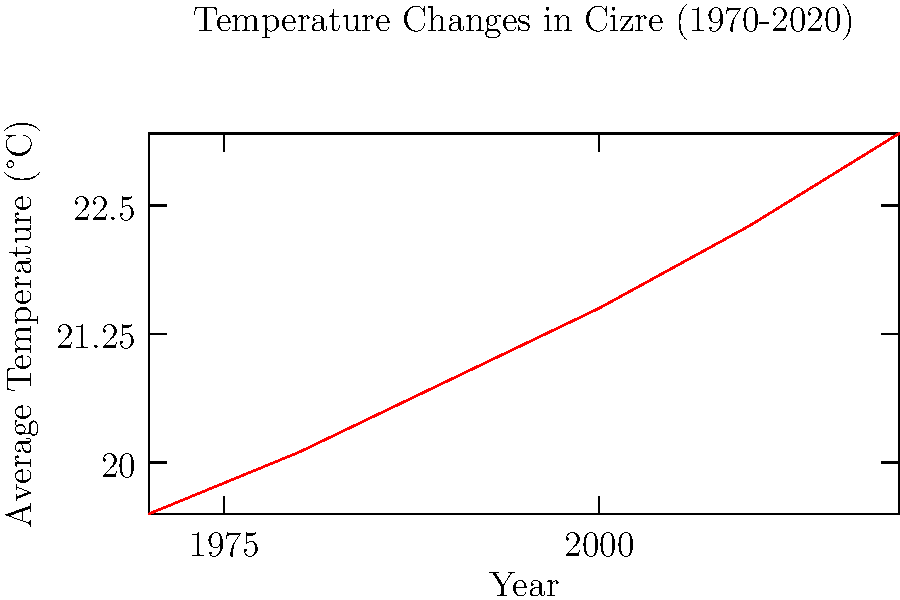Based on the line graph showing temperature changes in Cizre over the past 50 years, what is the approximate average rate of temperature increase per decade? To calculate the average rate of temperature increase per decade:

1. Calculate total temperature change:
   Final temperature (2020): 23.2°C
   Initial temperature (1970): 19.5°C
   Total change: 23.2°C - 19.5°C = 3.7°C

2. Calculate total time span:
   2020 - 1970 = 50 years

3. Calculate change per decade:
   $\frac{3.7\text{°C}}{50\text{ years}} \times 10\text{ years/decade} = 0.74\text{°C/decade}$

4. Round to one decimal place:
   0.74°C/decade ≈ 0.7°C/decade
Answer: 0.7°C/decade 